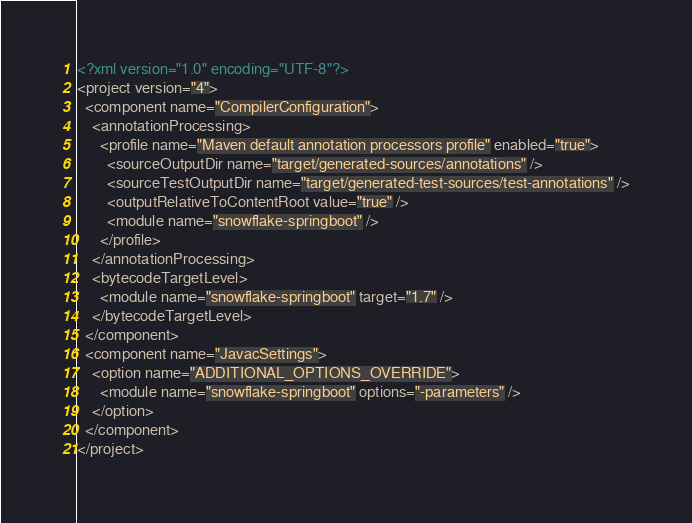Convert code to text. <code><loc_0><loc_0><loc_500><loc_500><_XML_><?xml version="1.0" encoding="UTF-8"?>
<project version="4">
  <component name="CompilerConfiguration">
    <annotationProcessing>
      <profile name="Maven default annotation processors profile" enabled="true">
        <sourceOutputDir name="target/generated-sources/annotations" />
        <sourceTestOutputDir name="target/generated-test-sources/test-annotations" />
        <outputRelativeToContentRoot value="true" />
        <module name="snowflake-springboot" />
      </profile>
    </annotationProcessing>
    <bytecodeTargetLevel>
      <module name="snowflake-springboot" target="1.7" />
    </bytecodeTargetLevel>
  </component>
  <component name="JavacSettings">
    <option name="ADDITIONAL_OPTIONS_OVERRIDE">
      <module name="snowflake-springboot" options="-parameters" />
    </option>
  </component>
</project></code> 